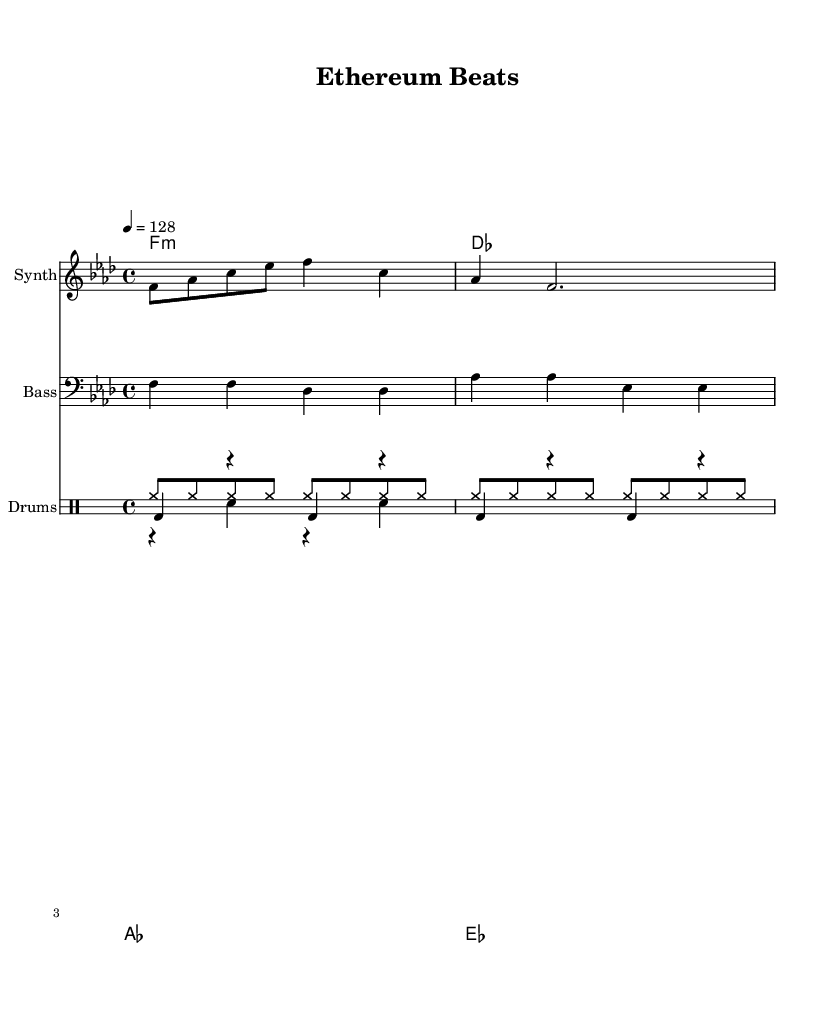What is the key signature of this music? The key signature is F minor, which has four flats (B♭, E♭, A♭, and D♭). This can be determined by looking at the key indicator in the global music section of the code, where it is defined as 'f \minor'.
Answer: F minor What is the time signature of this music? The time signature is 4/4, which is indicated in the global music section of the code. This means there are four beats per measure and a quarter note gets one beat.
Answer: 4/4 What is the tempo marking of this piece? The tempo marking indicates the speed of the piece, given as 128 beats per minute in the global music section. This is shown as '4 = 128', meaning each quarter note equals 128 beats per minute.
Answer: 128 How many measures are in the synth melody? The synth melody consists of four measures, as seen in the notation where there are four groupings before the final bar line. Each grouping represents a measure.
Answer: 4 What is the primary chord used in this piece? The primary chord indicated in the chord names section is F minor, as it is the first chord listed in the sequence 'f1:m'. This implies that the piece starts on this chord.
Answer: F minor Which instrument plays the bass line? The bass line is indicated to be played by a bass synth, as stated in the staff where the instrument is labeled 'Bass'. This shows that the notation is for synthesizer bass sounds.
Answer: Bass synth What rhythmic pattern is used for the drum kick? The drum kick pattern features a repetition of the bass drum hit every quarter note with rests in between, as shown in the 'drumKick' section of the code, which notates quarter notes for the bass drum throughout.
Answer: Quarter notes 